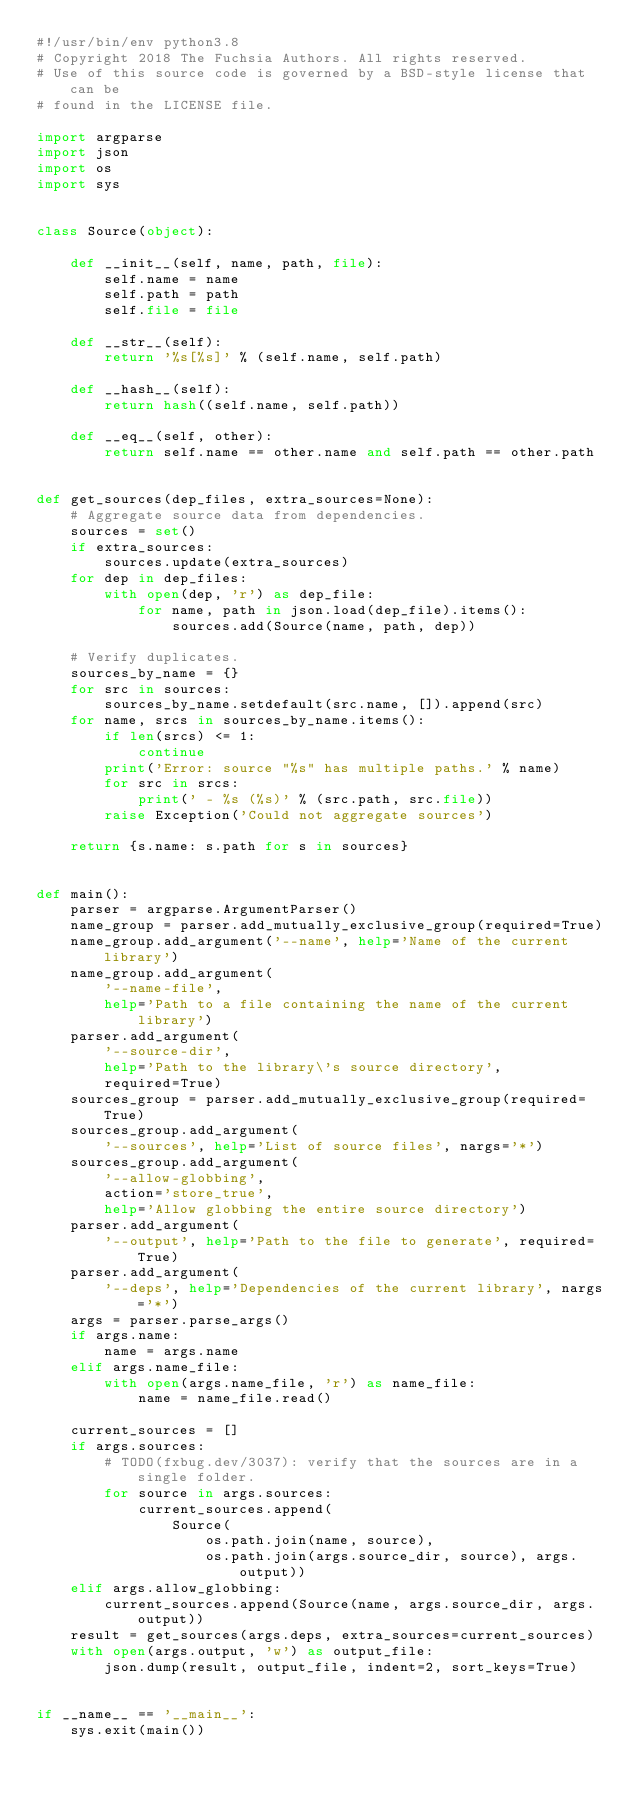Convert code to text. <code><loc_0><loc_0><loc_500><loc_500><_Python_>#!/usr/bin/env python3.8
# Copyright 2018 The Fuchsia Authors. All rights reserved.
# Use of this source code is governed by a BSD-style license that can be
# found in the LICENSE file.

import argparse
import json
import os
import sys


class Source(object):

    def __init__(self, name, path, file):
        self.name = name
        self.path = path
        self.file = file

    def __str__(self):
        return '%s[%s]' % (self.name, self.path)

    def __hash__(self):
        return hash((self.name, self.path))

    def __eq__(self, other):
        return self.name == other.name and self.path == other.path


def get_sources(dep_files, extra_sources=None):
    # Aggregate source data from dependencies.
    sources = set()
    if extra_sources:
        sources.update(extra_sources)
    for dep in dep_files:
        with open(dep, 'r') as dep_file:
            for name, path in json.load(dep_file).items():
                sources.add(Source(name, path, dep))

    # Verify duplicates.
    sources_by_name = {}
    for src in sources:
        sources_by_name.setdefault(src.name, []).append(src)
    for name, srcs in sources_by_name.items():
        if len(srcs) <= 1:
            continue
        print('Error: source "%s" has multiple paths.' % name)
        for src in srcs:
            print(' - %s (%s)' % (src.path, src.file))
        raise Exception('Could not aggregate sources')

    return {s.name: s.path for s in sources}


def main():
    parser = argparse.ArgumentParser()
    name_group = parser.add_mutually_exclusive_group(required=True)
    name_group.add_argument('--name', help='Name of the current library')
    name_group.add_argument(
        '--name-file',
        help='Path to a file containing the name of the current library')
    parser.add_argument(
        '--source-dir',
        help='Path to the library\'s source directory',
        required=True)
    sources_group = parser.add_mutually_exclusive_group(required=True)
    sources_group.add_argument(
        '--sources', help='List of source files', nargs='*')
    sources_group.add_argument(
        '--allow-globbing',
        action='store_true',
        help='Allow globbing the entire source directory')
    parser.add_argument(
        '--output', help='Path to the file to generate', required=True)
    parser.add_argument(
        '--deps', help='Dependencies of the current library', nargs='*')
    args = parser.parse_args()
    if args.name:
        name = args.name
    elif args.name_file:
        with open(args.name_file, 'r') as name_file:
            name = name_file.read()

    current_sources = []
    if args.sources:
        # TODO(fxbug.dev/3037): verify that the sources are in a single folder.
        for source in args.sources:
            current_sources.append(
                Source(
                    os.path.join(name, source),
                    os.path.join(args.source_dir, source), args.output))
    elif args.allow_globbing:
        current_sources.append(Source(name, args.source_dir, args.output))
    result = get_sources(args.deps, extra_sources=current_sources)
    with open(args.output, 'w') as output_file:
        json.dump(result, output_file, indent=2, sort_keys=True)


if __name__ == '__main__':
    sys.exit(main())
</code> 